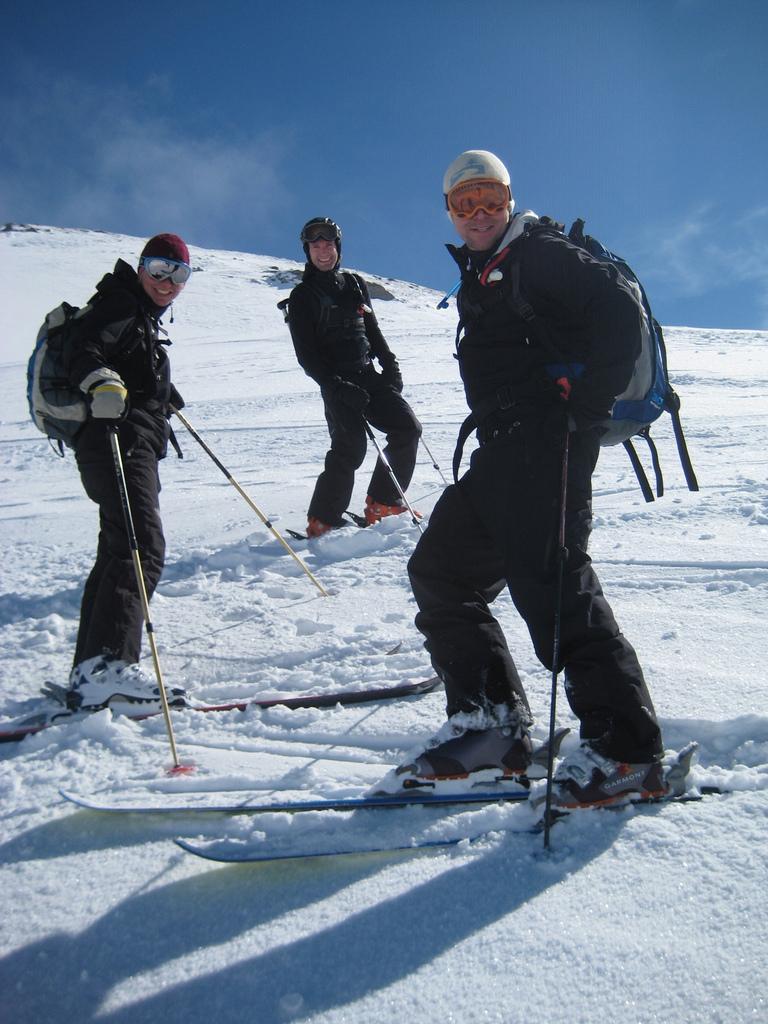How many men are not wearing goggles?
Give a very brief answer. 1. How many men are smiling at the camera?
Give a very brief answer. 3. 